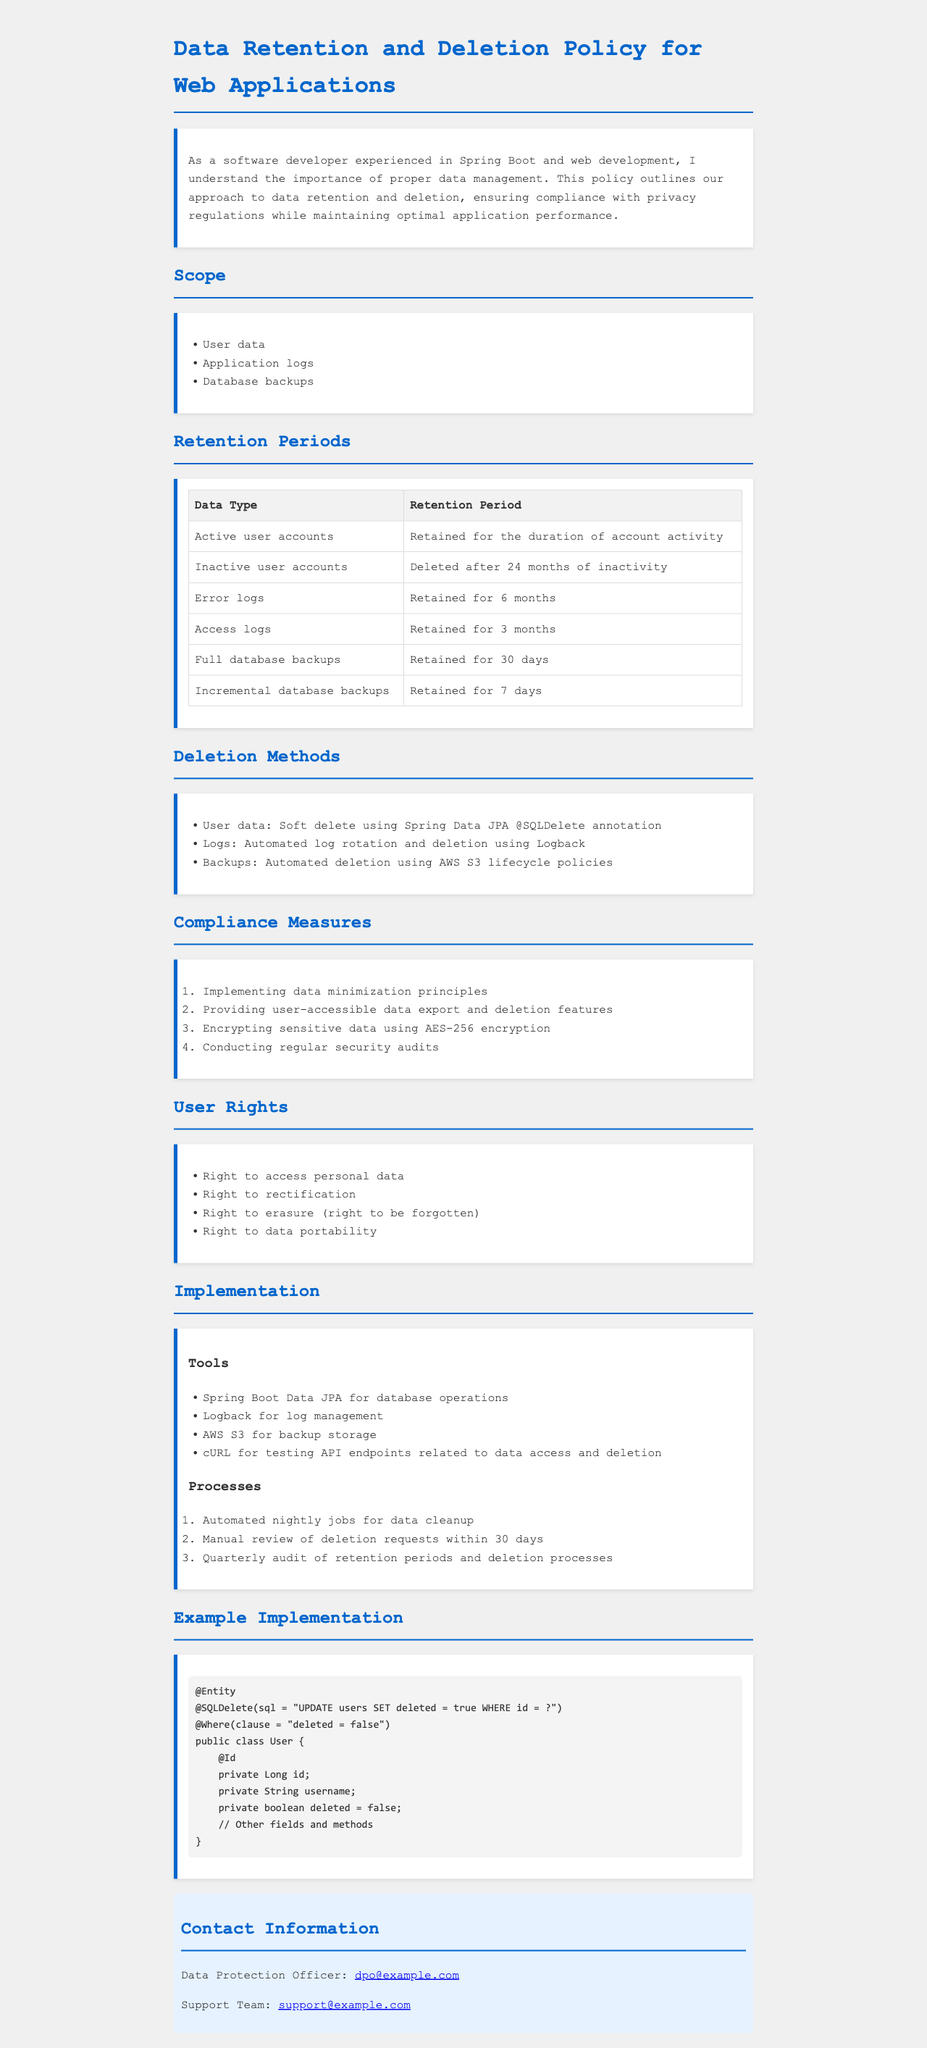What types of data are covered in the policy? The policy explicitly mentions three types of data: user data, application logs, and database backups.
Answer: User data, application logs, database backups How long are error logs retained? The document provides a retention period for error logs, specifically stating they are retained for six months.
Answer: Six months What deletion method is used for user data? The policy specifies the method used for deleting user data, which is a soft delete approach with a specific annotation in Java.
Answer: Soft delete using Spring Data JPA @SQLDelete annotation What is the retention period for inactive user accounts? The document states that inactive user accounts are deleted after a specified duration of inactivity.
Answer: Deleted after 24 months of inactivity What encryption standard is implemented for sensitive data? The policy outlines that sensitive data is encrypted using a specific encryption standard mentioned in the compliance measures.
Answer: AES-256 encryption What is the maximum time allowed for manual review of deletion requests? The policy specifies a time frame for manually reviewing deletion requests, which underscores the importance of timely action in this process.
Answer: 30 days How often are audits of retention periods conducted? The policy outlines the frequency of audits performed to ensure adherence to retention periods and the effectiveness of deletion processes.
Answer: Quarterly What tool is mentioned for managing logs? The document lists specific tools used for various operations, including the management of logs, one of which is explicitly named.
Answer: Logback What right allows users to request deletion of their personal data? The document enumerates user rights, one of which pertains to the ability to request the deletion of personal data.
Answer: Right to erasure (right to be forgotten) 